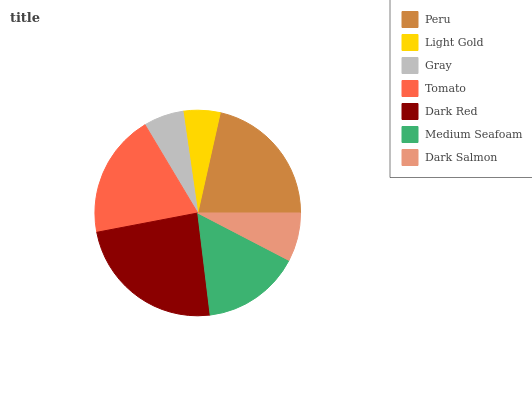Is Light Gold the minimum?
Answer yes or no. Yes. Is Dark Red the maximum?
Answer yes or no. Yes. Is Gray the minimum?
Answer yes or no. No. Is Gray the maximum?
Answer yes or no. No. Is Gray greater than Light Gold?
Answer yes or no. Yes. Is Light Gold less than Gray?
Answer yes or no. Yes. Is Light Gold greater than Gray?
Answer yes or no. No. Is Gray less than Light Gold?
Answer yes or no. No. Is Medium Seafoam the high median?
Answer yes or no. Yes. Is Medium Seafoam the low median?
Answer yes or no. Yes. Is Peru the high median?
Answer yes or no. No. Is Tomato the low median?
Answer yes or no. No. 